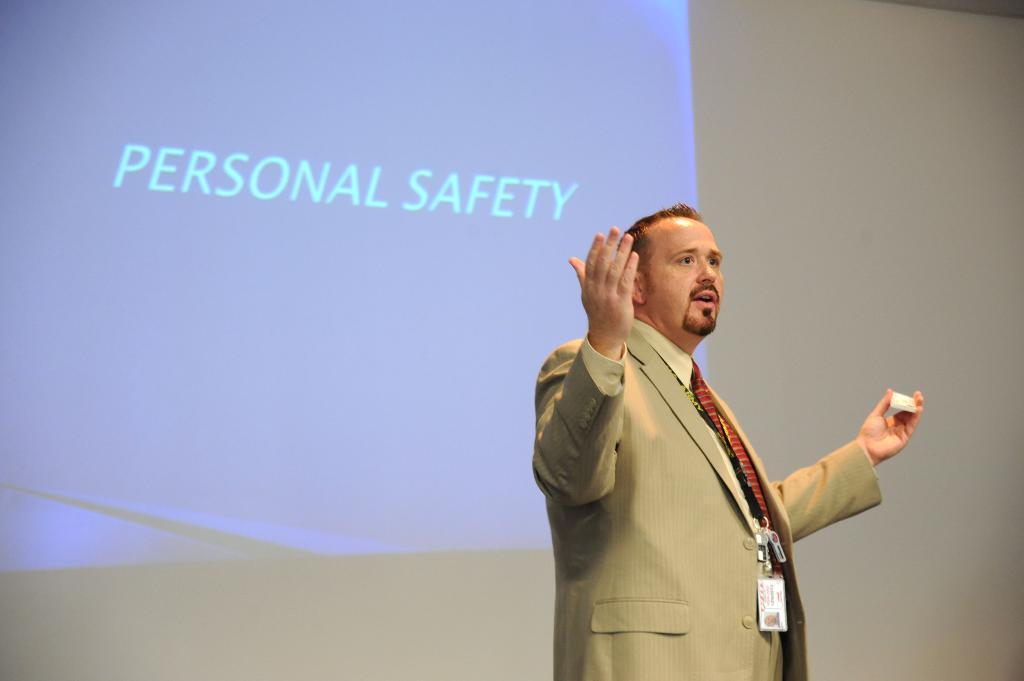In one or two sentences, can you explain what this image depicts? In this image there is a person on the stage and holding an object, there is some text on the screen. 